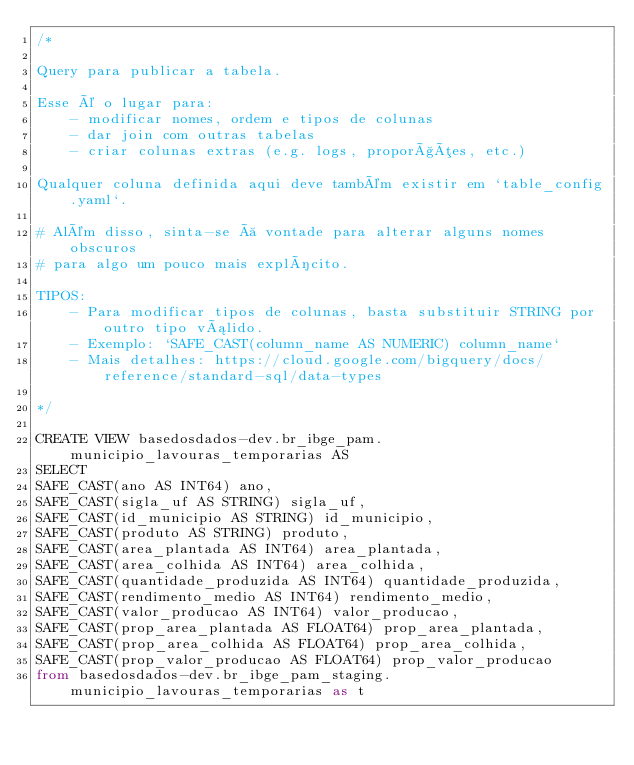Convert code to text. <code><loc_0><loc_0><loc_500><loc_500><_SQL_>/*

Query para publicar a tabela.

Esse é o lugar para:
    - modificar nomes, ordem e tipos de colunas
    - dar join com outras tabelas
    - criar colunas extras (e.g. logs, proporções, etc.)

Qualquer coluna definida aqui deve também existir em `table_config.yaml`.

# Além disso, sinta-se à vontade para alterar alguns nomes obscuros
# para algo um pouco mais explícito.

TIPOS:
    - Para modificar tipos de colunas, basta substituir STRING por outro tipo válido.
    - Exemplo: `SAFE_CAST(column_name AS NUMERIC) column_name`
    - Mais detalhes: https://cloud.google.com/bigquery/docs/reference/standard-sql/data-types

*/

CREATE VIEW basedosdados-dev.br_ibge_pam.municipio_lavouras_temporarias AS
SELECT 
SAFE_CAST(ano AS INT64) ano,
SAFE_CAST(sigla_uf AS STRING) sigla_uf,
SAFE_CAST(id_municipio AS STRING) id_municipio,
SAFE_CAST(produto AS STRING) produto,
SAFE_CAST(area_plantada AS INT64) area_plantada,
SAFE_CAST(area_colhida AS INT64) area_colhida,
SAFE_CAST(quantidade_produzida AS INT64) quantidade_produzida,
SAFE_CAST(rendimento_medio AS INT64) rendimento_medio,
SAFE_CAST(valor_producao AS INT64) valor_producao,
SAFE_CAST(prop_area_plantada AS FLOAT64) prop_area_plantada,
SAFE_CAST(prop_area_colhida AS FLOAT64) prop_area_colhida,
SAFE_CAST(prop_valor_producao AS FLOAT64) prop_valor_producao
from basedosdados-dev.br_ibge_pam_staging.municipio_lavouras_temporarias as t</code> 